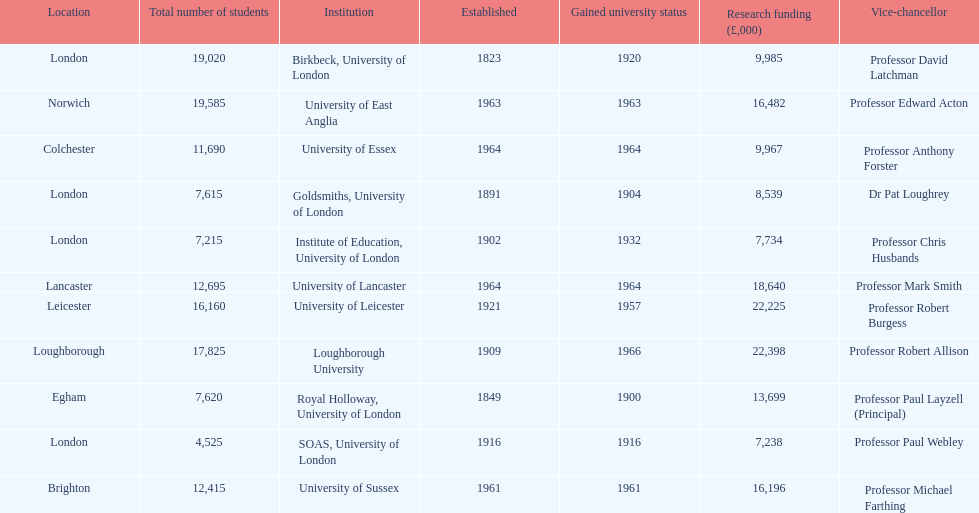What are the names of all the institutions? Birkbeck, University of London, University of East Anglia, University of Essex, Goldsmiths, University of London, Institute of Education, University of London, University of Lancaster, University of Leicester, Loughborough University, Royal Holloway, University of London, SOAS, University of London, University of Sussex. In what range of years were these institutions established? 1823, 1963, 1964, 1891, 1902, 1964, 1921, 1909, 1849, 1916, 1961. In what range of years did these institutions gain university status? 1920, 1963, 1964, 1904, 1932, 1964, 1957, 1966, 1900, 1916, 1961. What institution most recently gained university status? Loughborough University. 